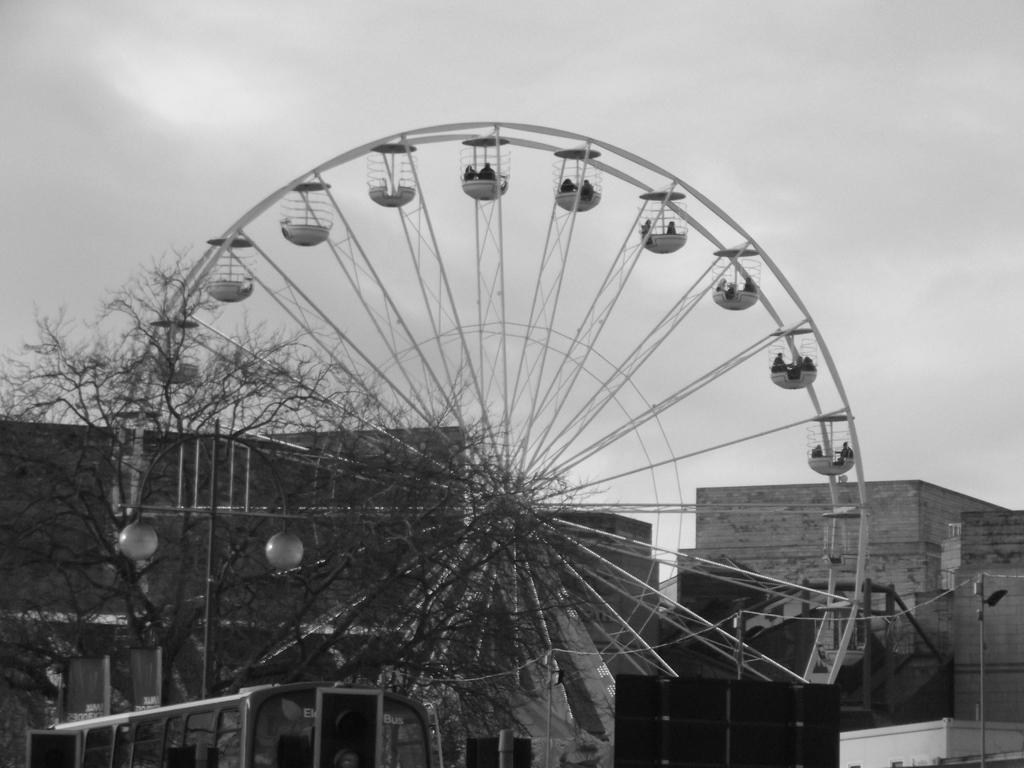What is the main structure visible in the image? There is a giant wheel in the image. What type of buildings can be seen in the image? There are houses in the image. What other natural elements are present in the image? There are trees in the image. What letters are being used to support the giant wheel in the image? There are no letters present in the image to support the giant wheel; it is a standalone structure. 